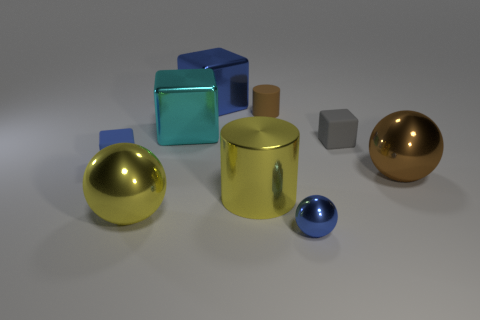What material do the objects in the image seem to be made of, based on their appearance? The objects in the image exhibit characteristics consistent with smooth, reflective metals, suggesting they might be composed of materials such as steel, aluminum, or perhaps a treated alloy for aesthetic purposes. 